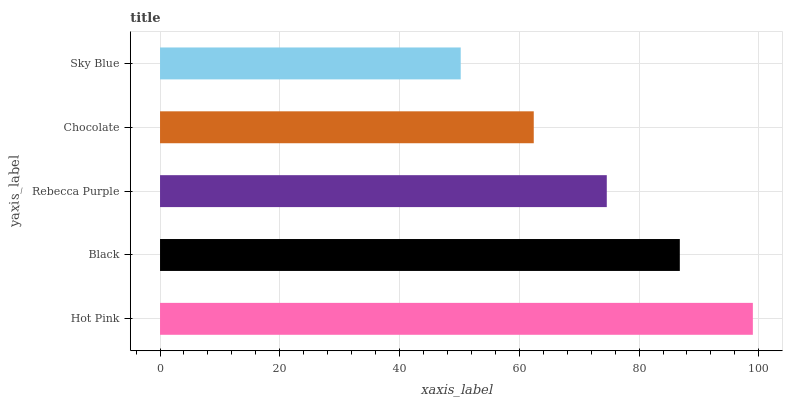Is Sky Blue the minimum?
Answer yes or no. Yes. Is Hot Pink the maximum?
Answer yes or no. Yes. Is Black the minimum?
Answer yes or no. No. Is Black the maximum?
Answer yes or no. No. Is Hot Pink greater than Black?
Answer yes or no. Yes. Is Black less than Hot Pink?
Answer yes or no. Yes. Is Black greater than Hot Pink?
Answer yes or no. No. Is Hot Pink less than Black?
Answer yes or no. No. Is Rebecca Purple the high median?
Answer yes or no. Yes. Is Rebecca Purple the low median?
Answer yes or no. Yes. Is Sky Blue the high median?
Answer yes or no. No. Is Black the low median?
Answer yes or no. No. 